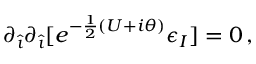Convert formula to latex. <formula><loc_0><loc_0><loc_500><loc_500>\partial _ { \hat { \imath } } \partial _ { \hat { \imath } } [ e ^ { - \frac { 1 } { 2 } ( U + i \theta ) } \epsilon _ { I } ] = 0 \, ,</formula> 